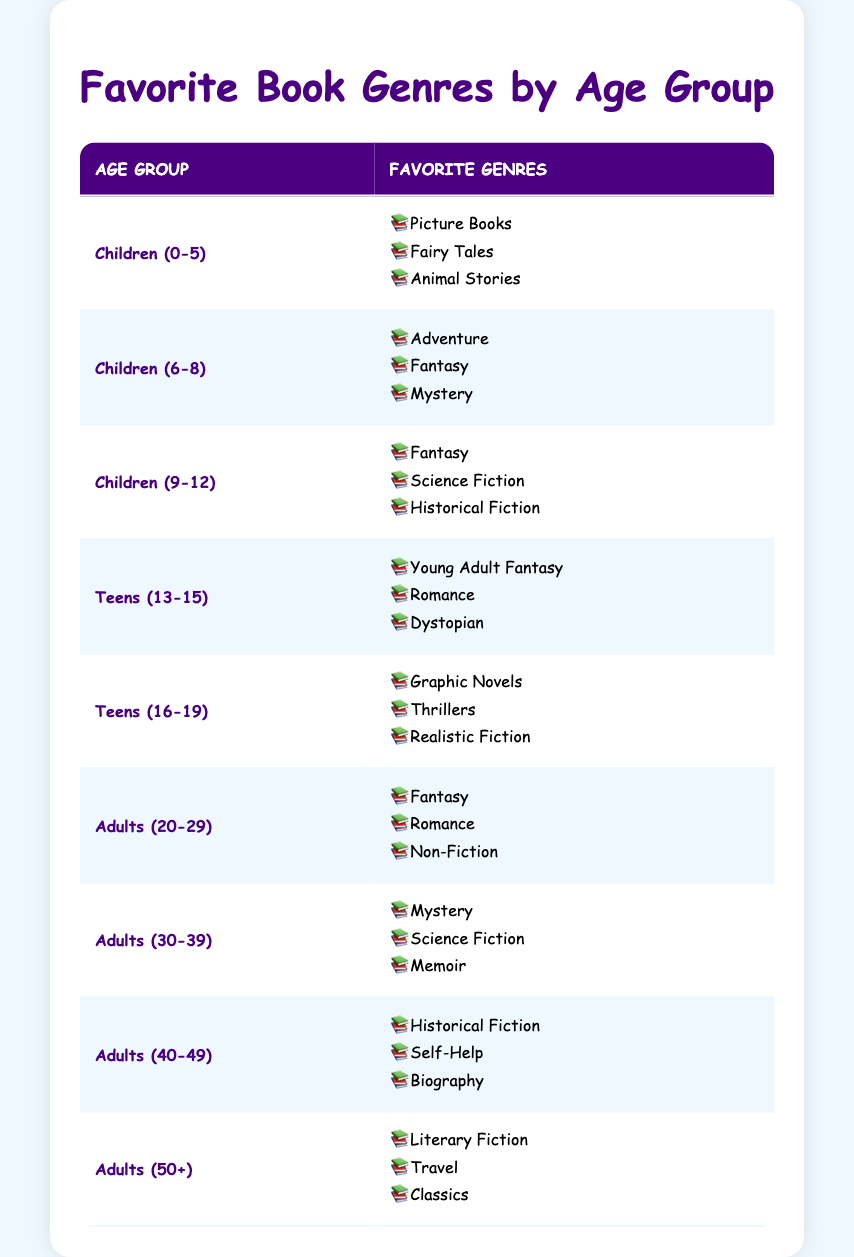What's the favorite book genre for 0-5-year-olds? The table shows that the favorite genres for the age group 0-5 are Picture Books, Fairy Tales, and Animal Stories.
Answer: Picture Books, Fairy Tales, Animal Stories Which age group enjoys Fantasy the most? The table indicates that Fantasy is listed as a favorite genre for the groups 9-12 (Children) and 13-15 (Teens) and again for Adults (20-29). However, the largest group listed is for Children (9-12).
Answer: Children (9-12) Do Teens aged 16-19 prefer Dystopian novels? The table explicitly states that Dystopian is among the favorite genres for Teens in the age group 16-19.
Answer: Yes How many different genres do Adults aged 30-39 enjoy? From the table, it can be seen that the age group 30-39 enjoys three genres: Mystery, Science Fiction, and Memoir. Therefore, the answer is 3.
Answer: 3 What genres are common between Children aged 6-8 and Adults aged 20-29? By looking at the favored genres for Children (6-8) which are Adventure, Fantasy and Mystery and for Adults (20-29) which are Fantasy, Romance, and Non-Fiction, the common genre is Fantasy.
Answer: Fantasy Which group has more diverse genre preferences, Teens aged 13-15 or Adults aged 40-49? Teens (13-15) have Young Adult Fantasy, Romance, and Dystopian (3 genres), while Adults (40-49) have Historical Fiction, Self-Help, and Biography (also 3 genres). Both groups have the same number of genres, making the diversity equal.
Answer: Equal diversity How many genres do Children aged 9-12 like compared to Adults aged 30-39? Children (9-12) like three genres: Fantasy, Science Fiction, and Historical Fiction, while Adults (30-39) also like three genres: Mystery, Science Fiction, and Memoir. Therefore, both groups share the same number of preferred genres.
Answer: They like the same number (3 genres) Are there any genres enjoyed by both teens and adults? The table shows that both groups favor Fantasy: Teens (13-15) and Adults (20-29). Therefore, at least Fantasy is enjoyed by both age groups.
Answer: Yes, Fantasy What is the sum total of favorite genres for all Children age groups? Adding the genres for Children (0-5 has 3, 6-8 has 3, and 9-12 has 3) gives a total of 3 + 3 + 3 = 9 genres across all Children age groups.
Answer: 9 genres What is the age group that prefers the least number of genres? By inspecting the table, all age groups have three genres listed, which indicates an equal number, and thus no group prefers fewer genres than the others.
Answer: Equal across groups 